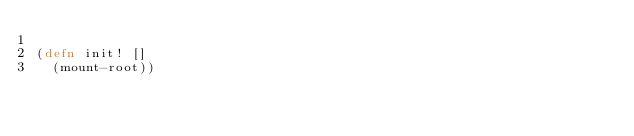Convert code to text. <code><loc_0><loc_0><loc_500><loc_500><_Clojure_>
(defn init! []
  (mount-root))
</code> 